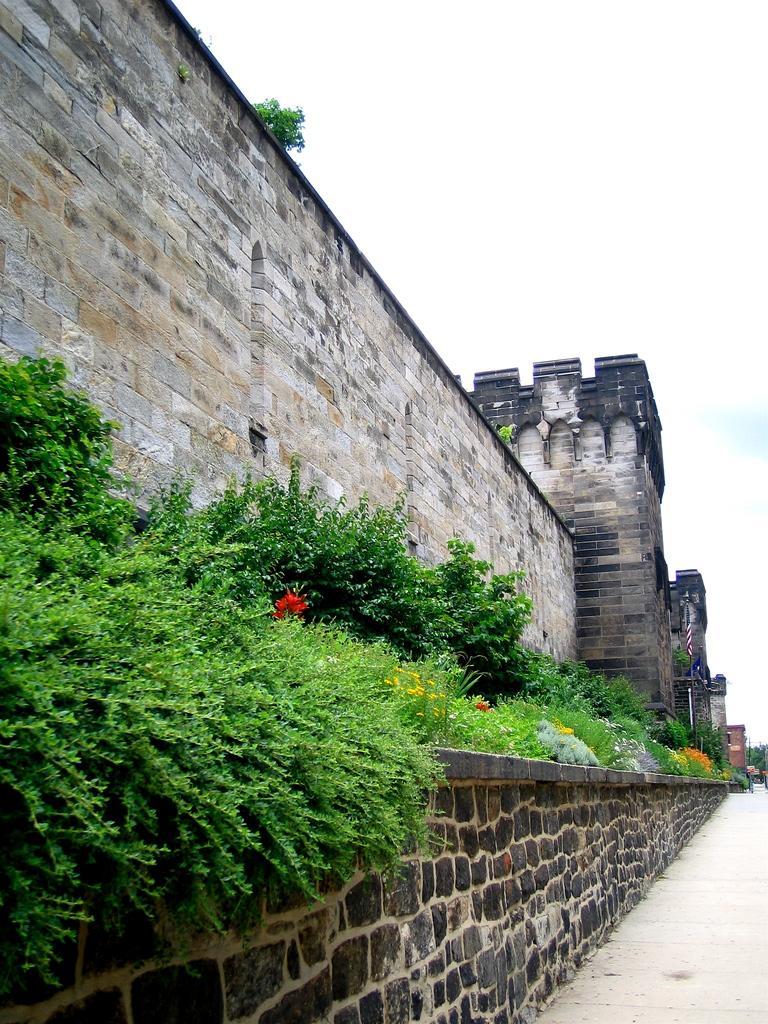How would you summarize this image in a sentence or two? Here we can see plants and flowers. This is wall. In the background we can see a flag, buildings, and sky. 